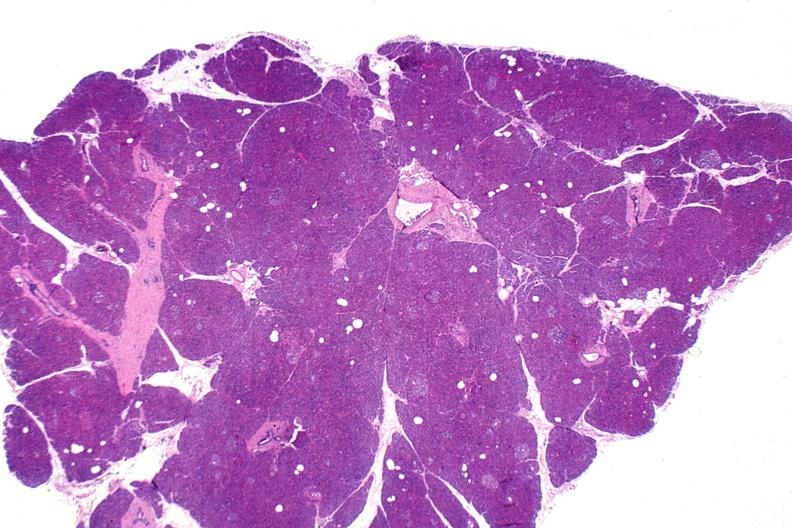what does this image show?
Answer the question using a single word or phrase. Normal pancreas 